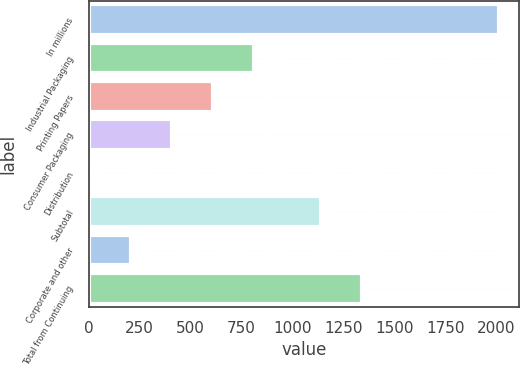Convert chart. <chart><loc_0><loc_0><loc_500><loc_500><bar_chart><fcel>In millions<fcel>Industrial Packaging<fcel>Printing Papers<fcel>Consumer Packaging<fcel>Distribution<fcel>Subtotal<fcel>Corporate and other<fcel>Total from Continuing<nl><fcel>2013<fcel>810.6<fcel>610.2<fcel>409.8<fcel>9<fcel>1140<fcel>209.4<fcel>1340.4<nl></chart> 